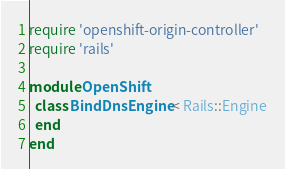Convert code to text. <code><loc_0><loc_0><loc_500><loc_500><_Ruby_>require 'openshift-origin-controller'
require 'rails'

module OpenShift
  class BindDnsEngine < Rails::Engine
  end
end
</code> 